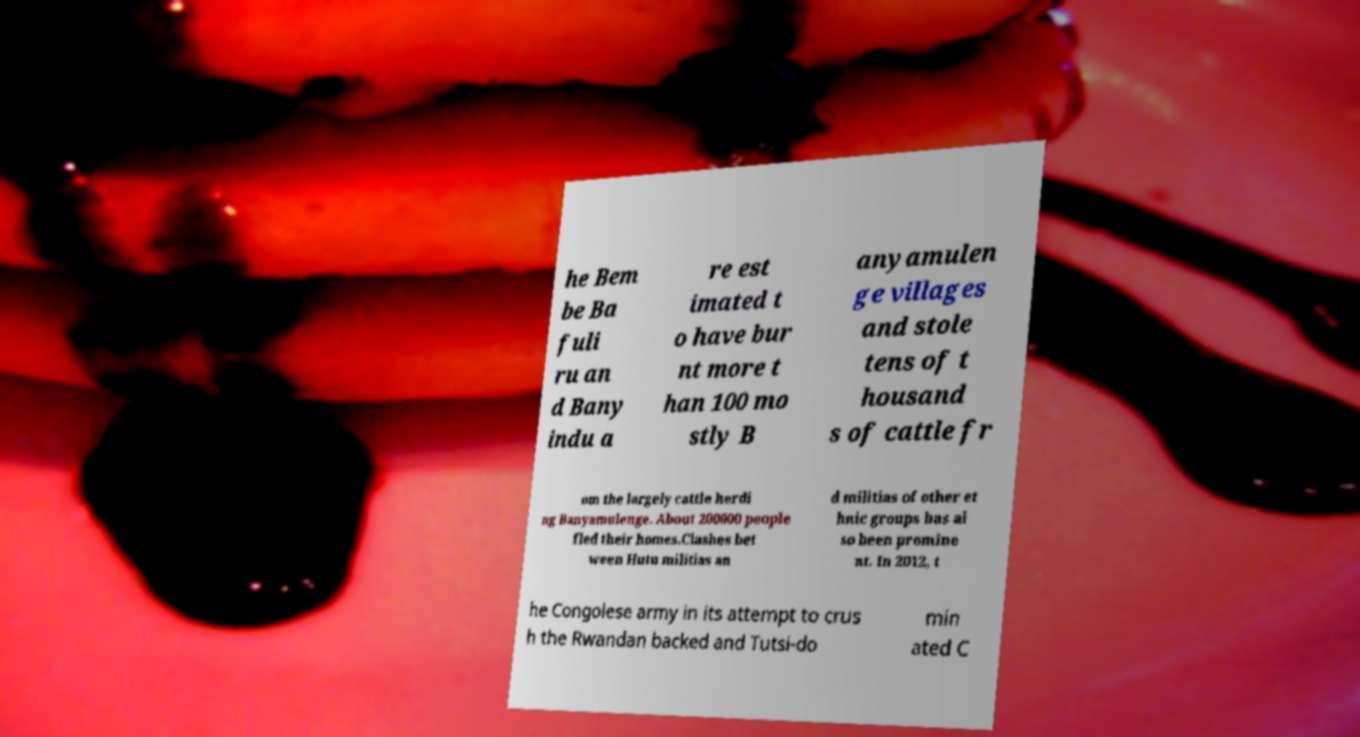Could you extract and type out the text from this image? he Bem be Ba fuli ru an d Bany indu a re est imated t o have bur nt more t han 100 mo stly B anyamulen ge villages and stole tens of t housand s of cattle fr om the largely cattle herdi ng Banyamulenge. About 200000 people fled their homes.Clashes bet ween Hutu militias an d militias of other et hnic groups has al so been promine nt. In 2012, t he Congolese army in its attempt to crus h the Rwandan backed and Tutsi-do min ated C 